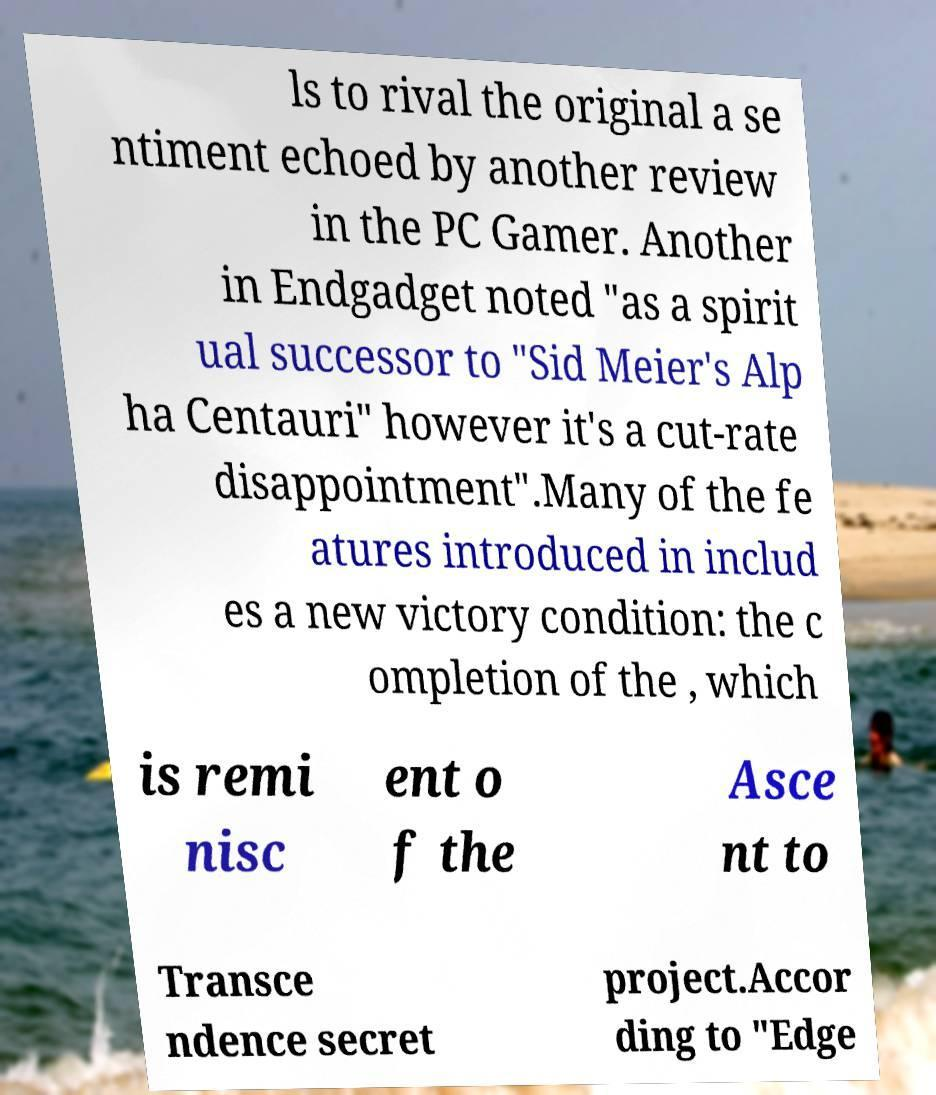Could you extract and type out the text from this image? ls to rival the original a se ntiment echoed by another review in the PC Gamer. Another in Endgadget noted "as a spirit ual successor to "Sid Meier's Alp ha Centauri" however it's a cut-rate disappointment".Many of the fe atures introduced in includ es a new victory condition: the c ompletion of the , which is remi nisc ent o f the Asce nt to Transce ndence secret project.Accor ding to "Edge 